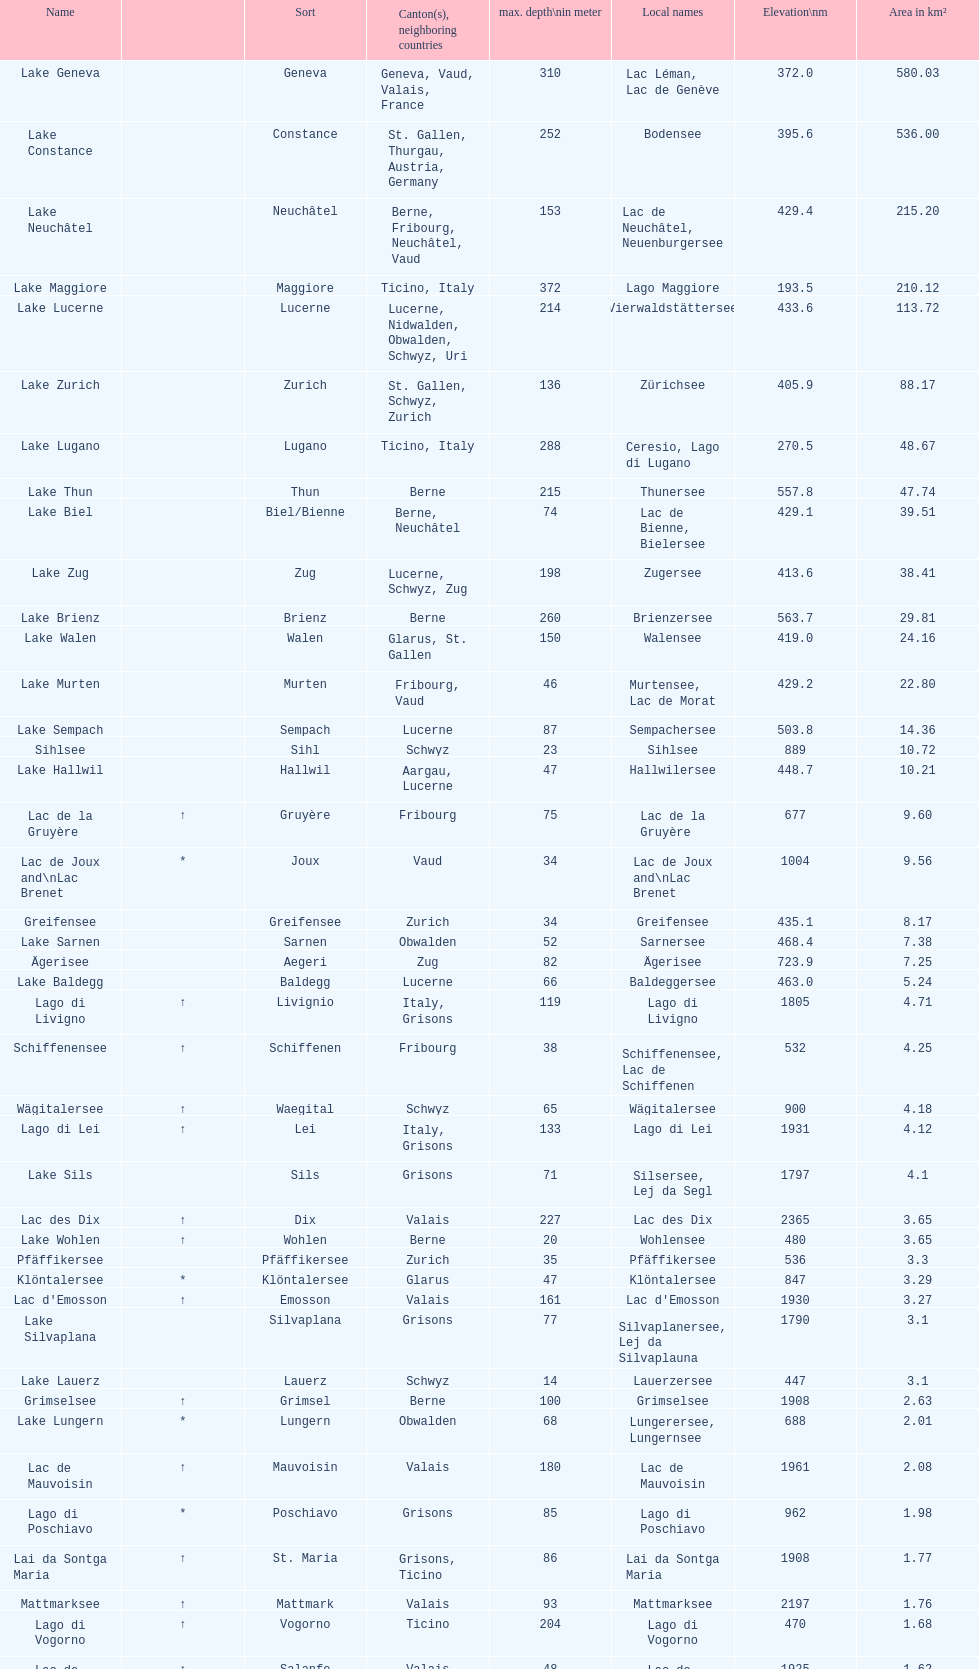Which lake is smaller in area km²? albigna lake or oeschinen lake? Oeschinen Lake. 